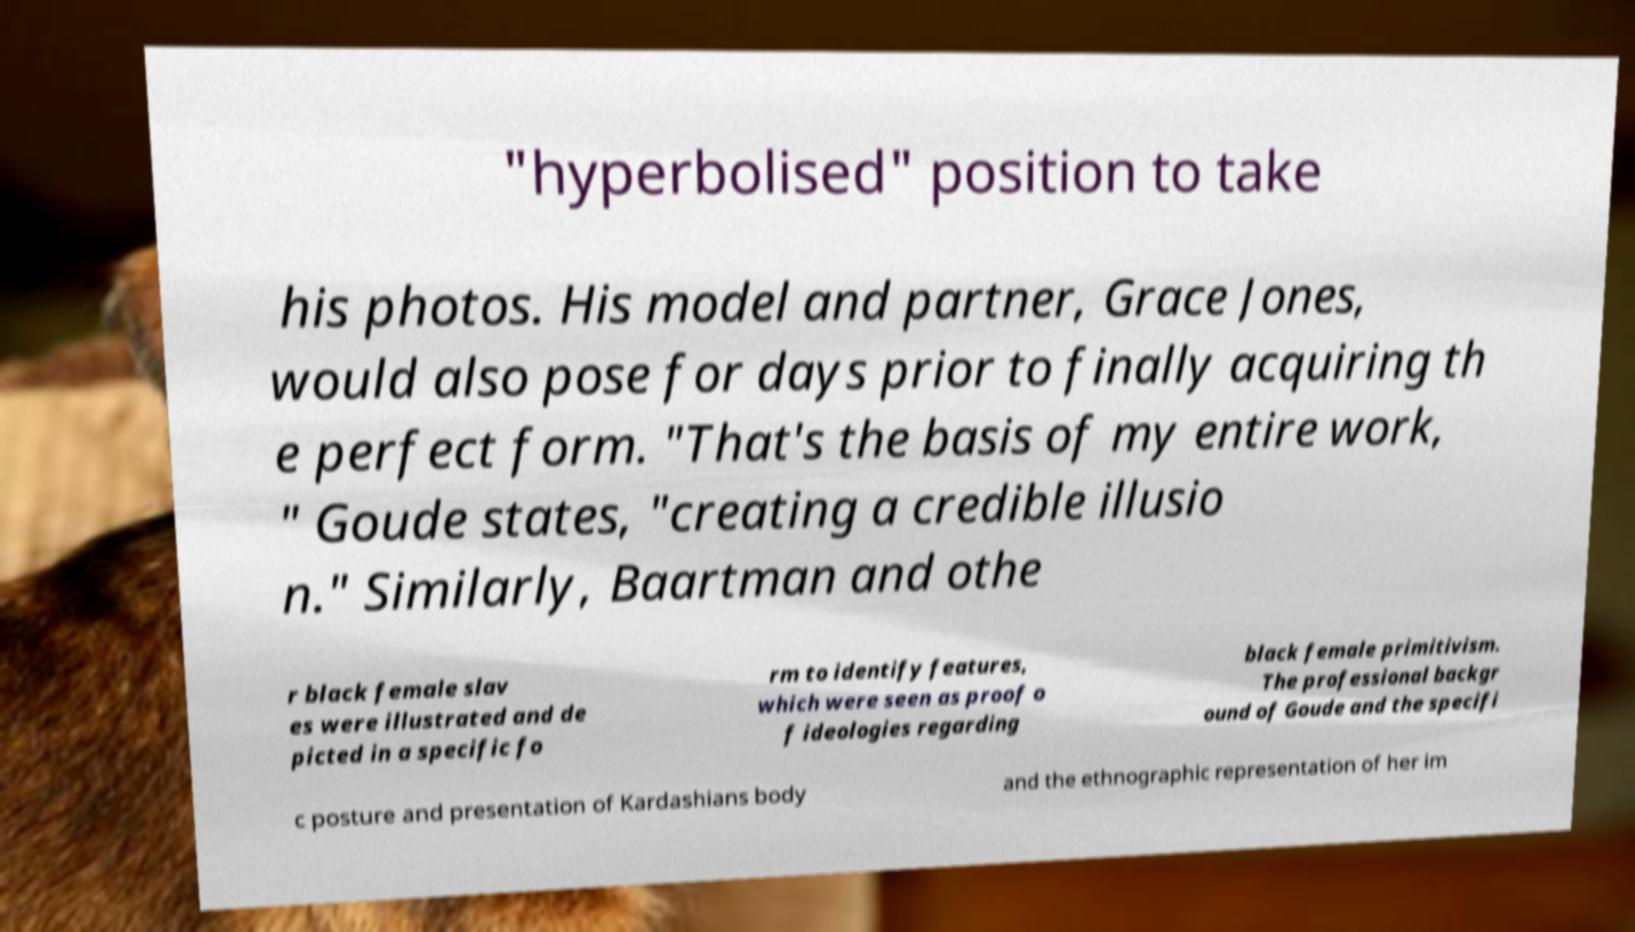Could you extract and type out the text from this image? "hyperbolised" position to take his photos. His model and partner, Grace Jones, would also pose for days prior to finally acquiring th e perfect form. "That's the basis of my entire work, " Goude states, "creating a credible illusio n." Similarly, Baartman and othe r black female slav es were illustrated and de picted in a specific fo rm to identify features, which were seen as proof o f ideologies regarding black female primitivism. The professional backgr ound of Goude and the specifi c posture and presentation of Kardashians body and the ethnographic representation of her im 